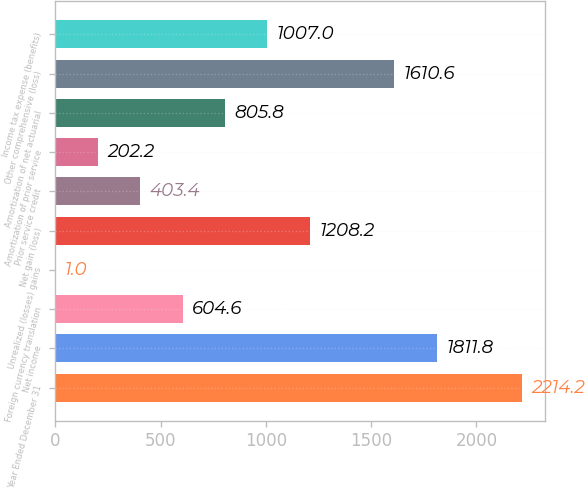Convert chart. <chart><loc_0><loc_0><loc_500><loc_500><bar_chart><fcel>Year Ended December 31<fcel>Net income<fcel>Foreign currency translation<fcel>Unrealized (losses) gains<fcel>Net gain (loss)<fcel>Prior service credit<fcel>Amortization of prior service<fcel>Amortization of net actuarial<fcel>Other comprehensive (loss)<fcel>Income tax expense (benefits)<nl><fcel>2214.2<fcel>1811.8<fcel>604.6<fcel>1<fcel>1208.2<fcel>403.4<fcel>202.2<fcel>805.8<fcel>1610.6<fcel>1007<nl></chart> 